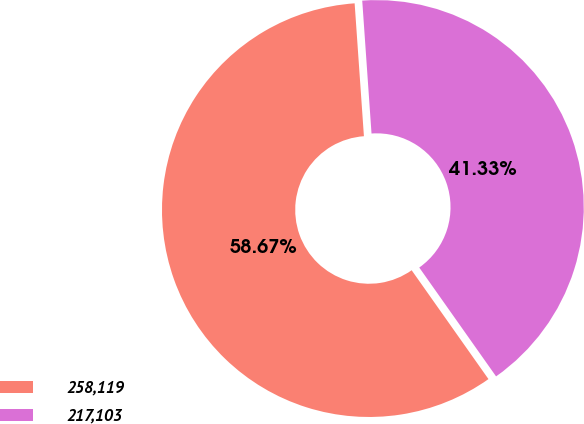Convert chart to OTSL. <chart><loc_0><loc_0><loc_500><loc_500><pie_chart><fcel>258,119<fcel>217,103<nl><fcel>58.67%<fcel>41.33%<nl></chart> 